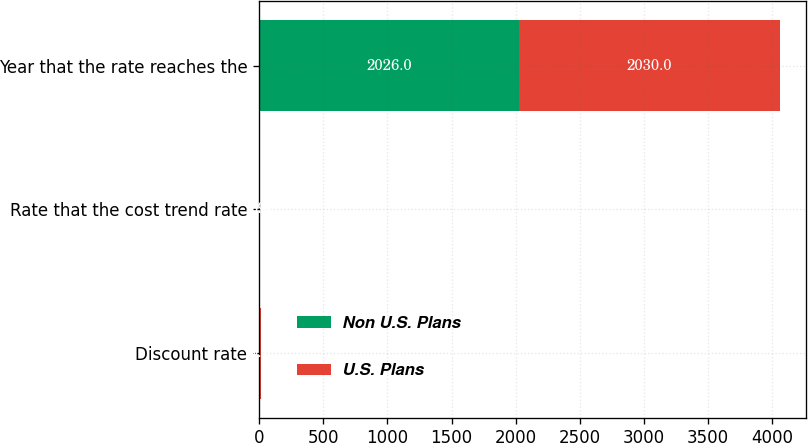Convert chart. <chart><loc_0><loc_0><loc_500><loc_500><stacked_bar_chart><ecel><fcel>Discount rate<fcel>Rate that the cost trend rate<fcel>Year that the rate reaches the<nl><fcel>Non U.S. Plans<fcel>4.2<fcel>5<fcel>2026<nl><fcel>U.S. Plans<fcel>9.1<fcel>4.93<fcel>2030<nl></chart> 